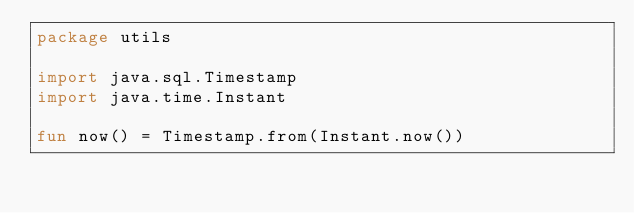Convert code to text. <code><loc_0><loc_0><loc_500><loc_500><_Kotlin_>package utils

import java.sql.Timestamp
import java.time.Instant

fun now() = Timestamp.from(Instant.now())
</code> 